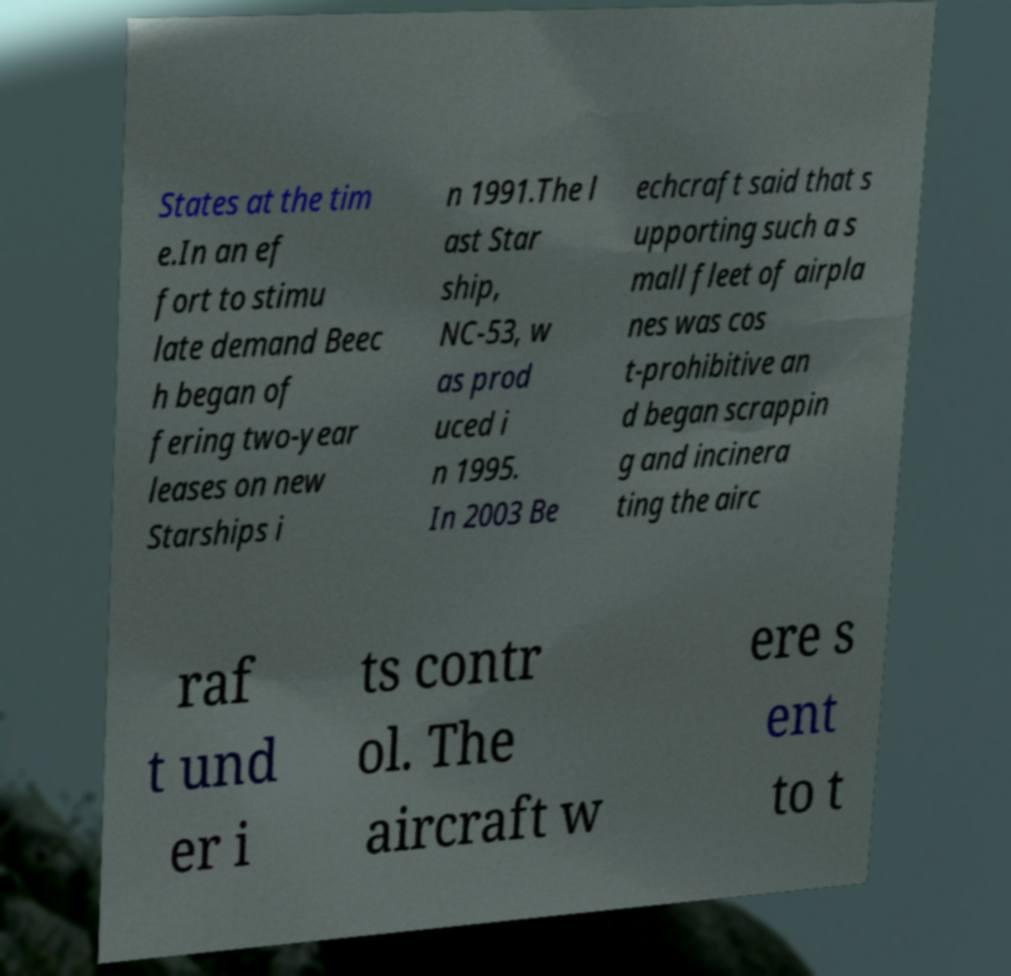There's text embedded in this image that I need extracted. Can you transcribe it verbatim? States at the tim e.In an ef fort to stimu late demand Beec h began of fering two-year leases on new Starships i n 1991.The l ast Star ship, NC-53, w as prod uced i n 1995. In 2003 Be echcraft said that s upporting such a s mall fleet of airpla nes was cos t-prohibitive an d began scrappin g and incinera ting the airc raf t und er i ts contr ol. The aircraft w ere s ent to t 